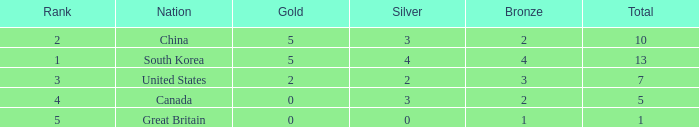What is the lowest Rank, when Nation is Great Britain, and when Bronze is less than 1? None. 